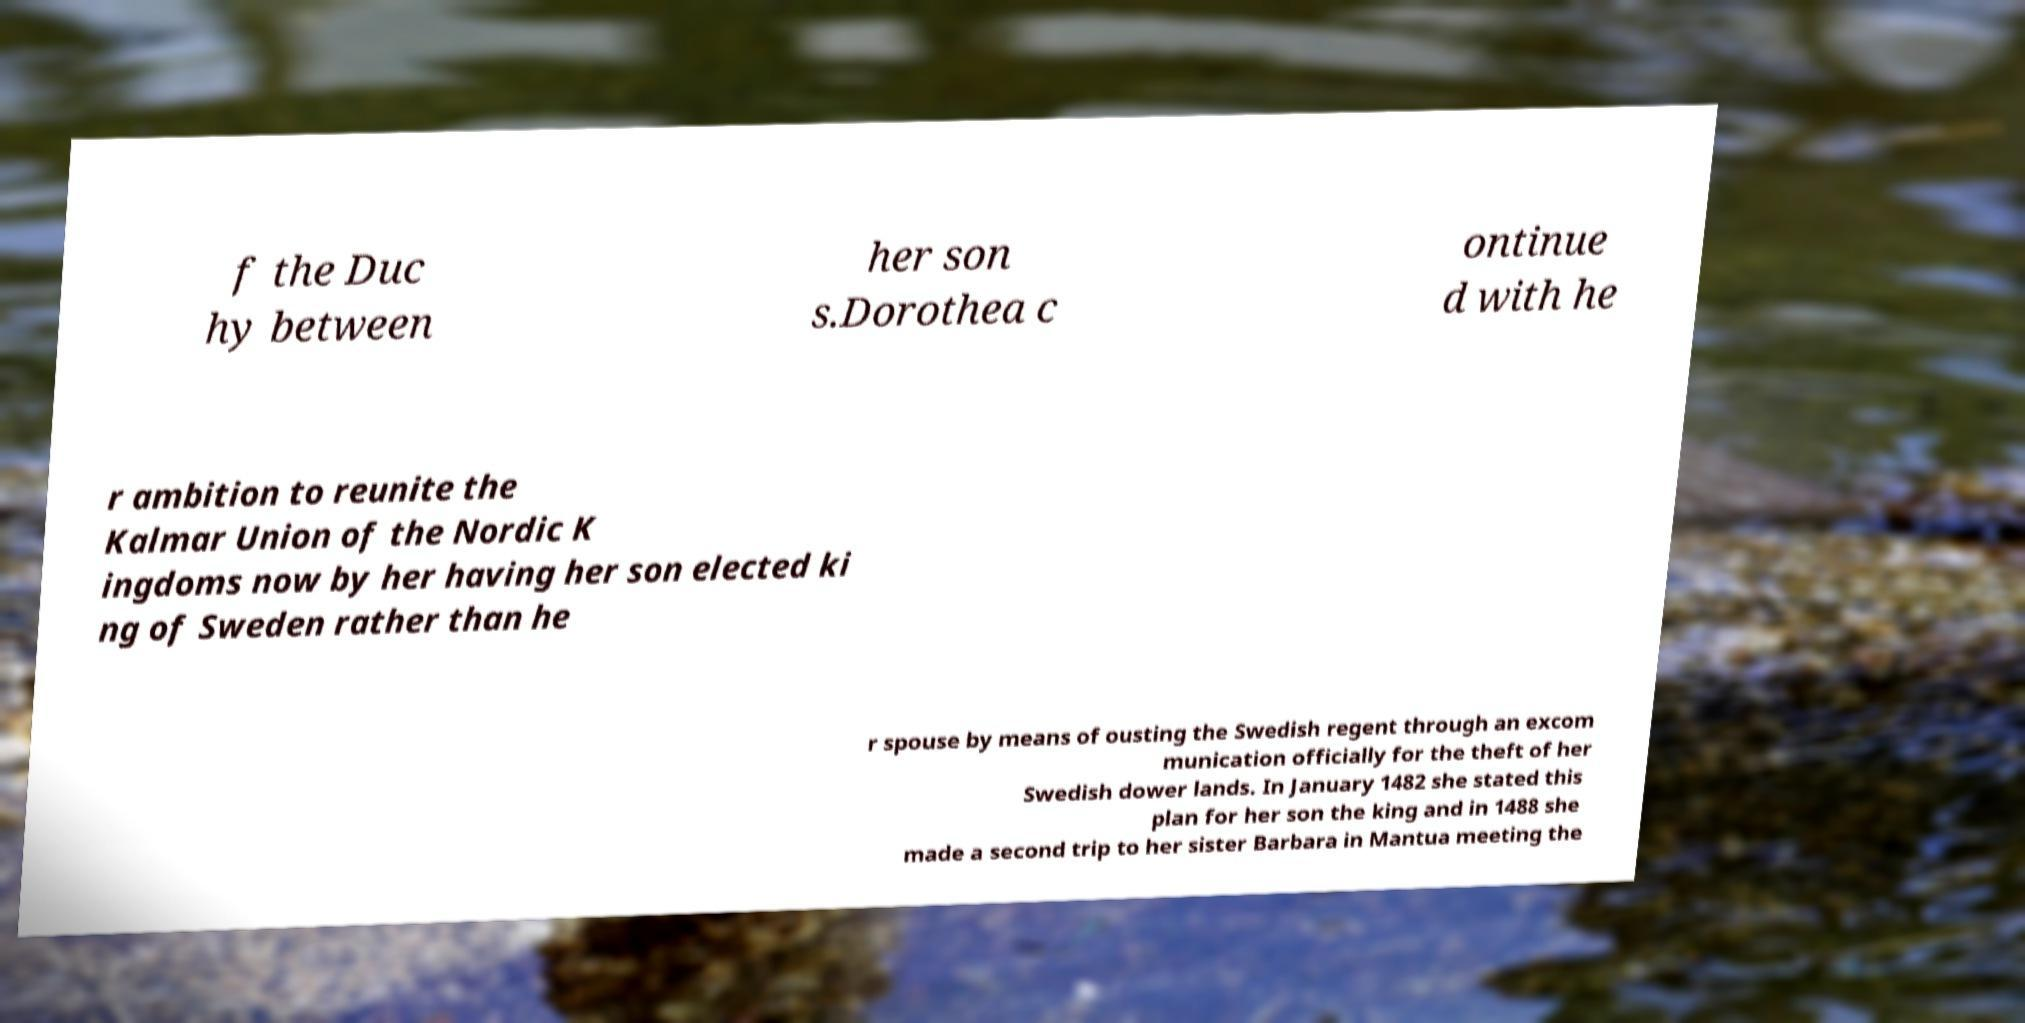Please read and relay the text visible in this image. What does it say? f the Duc hy between her son s.Dorothea c ontinue d with he r ambition to reunite the Kalmar Union of the Nordic K ingdoms now by her having her son elected ki ng of Sweden rather than he r spouse by means of ousting the Swedish regent through an excom munication officially for the theft of her Swedish dower lands. In January 1482 she stated this plan for her son the king and in 1488 she made a second trip to her sister Barbara in Mantua meeting the 